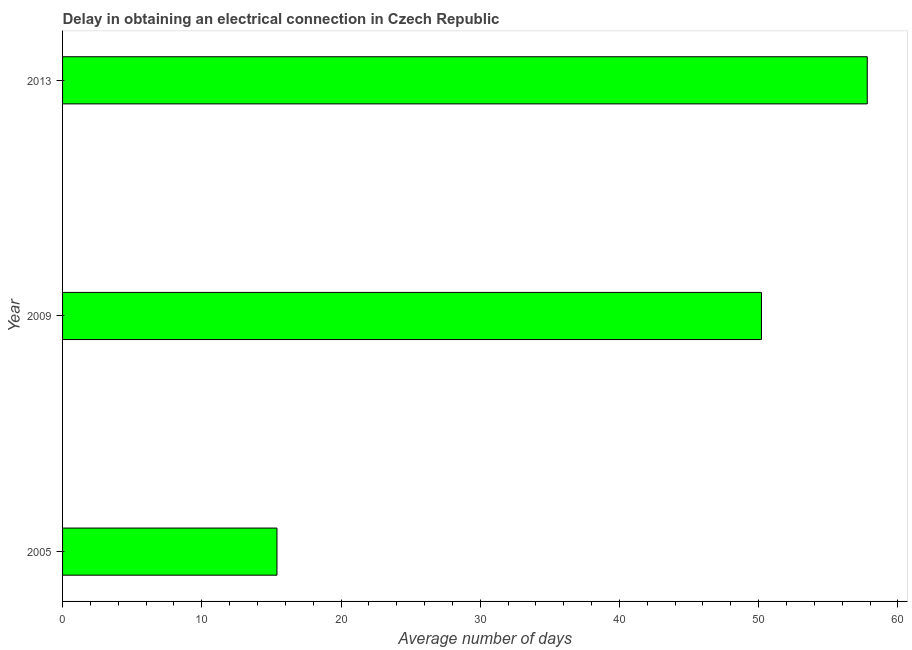Does the graph contain any zero values?
Provide a succinct answer. No. Does the graph contain grids?
Provide a short and direct response. No. What is the title of the graph?
Give a very brief answer. Delay in obtaining an electrical connection in Czech Republic. What is the label or title of the X-axis?
Provide a succinct answer. Average number of days. What is the dalay in electrical connection in 2013?
Your answer should be compact. 57.8. Across all years, what is the maximum dalay in electrical connection?
Provide a succinct answer. 57.8. What is the sum of the dalay in electrical connection?
Make the answer very short. 123.4. What is the difference between the dalay in electrical connection in 2005 and 2009?
Ensure brevity in your answer.  -34.8. What is the average dalay in electrical connection per year?
Provide a succinct answer. 41.13. What is the median dalay in electrical connection?
Keep it short and to the point. 50.2. What is the ratio of the dalay in electrical connection in 2005 to that in 2009?
Ensure brevity in your answer.  0.31. Is the dalay in electrical connection in 2005 less than that in 2013?
Ensure brevity in your answer.  Yes. Is the difference between the dalay in electrical connection in 2009 and 2013 greater than the difference between any two years?
Give a very brief answer. No. What is the difference between the highest and the second highest dalay in electrical connection?
Your answer should be very brief. 7.6. What is the difference between the highest and the lowest dalay in electrical connection?
Your answer should be very brief. 42.4. In how many years, is the dalay in electrical connection greater than the average dalay in electrical connection taken over all years?
Make the answer very short. 2. Are all the bars in the graph horizontal?
Offer a very short reply. Yes. How many years are there in the graph?
Your answer should be compact. 3. What is the difference between two consecutive major ticks on the X-axis?
Your answer should be very brief. 10. Are the values on the major ticks of X-axis written in scientific E-notation?
Your response must be concise. No. What is the Average number of days in 2005?
Give a very brief answer. 15.4. What is the Average number of days of 2009?
Provide a succinct answer. 50.2. What is the Average number of days in 2013?
Provide a short and direct response. 57.8. What is the difference between the Average number of days in 2005 and 2009?
Provide a succinct answer. -34.8. What is the difference between the Average number of days in 2005 and 2013?
Keep it short and to the point. -42.4. What is the ratio of the Average number of days in 2005 to that in 2009?
Offer a very short reply. 0.31. What is the ratio of the Average number of days in 2005 to that in 2013?
Provide a short and direct response. 0.27. What is the ratio of the Average number of days in 2009 to that in 2013?
Offer a terse response. 0.87. 